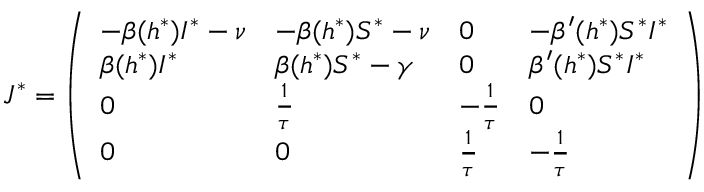<formula> <loc_0><loc_0><loc_500><loc_500>J ^ { * } = \left ( \begin{array} { l l l l } { - \beta ( h ^ { * } ) I ^ { * } - \nu } & { - \beta ( h ^ { * } ) S ^ { * } - \nu } & { 0 } & { - \beta ^ { \prime } ( h ^ { * } ) S ^ { * } I ^ { * } } \\ { \beta ( h ^ { * } ) I ^ { * } } & { \beta ( h ^ { * } ) S ^ { * } - \gamma } & { 0 } & { \beta ^ { \prime } ( h ^ { * } ) S ^ { * } I ^ { * } } \\ { 0 } & { \frac { 1 } { \tau } } & { - \frac { 1 } { \tau } } & { 0 } \\ { 0 } & { 0 } & { \frac { 1 } { \tau } } & { - \frac { 1 } { \tau } } \end{array} \right )</formula> 